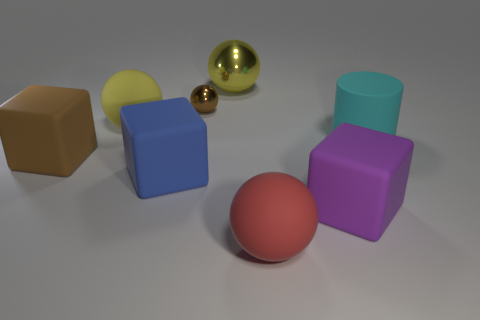Subtract all large brown blocks. How many blocks are left? 2 Add 1 red matte objects. How many objects exist? 9 Subtract all yellow balls. How many balls are left? 2 Subtract 1 cylinders. How many cylinders are left? 0 Subtract all cubes. How many objects are left? 5 Subtract all cyan cubes. Subtract all red spheres. How many cubes are left? 3 Add 3 tiny shiny balls. How many tiny shiny balls exist? 4 Subtract 0 green spheres. How many objects are left? 8 Subtract all cyan blocks. How many green spheres are left? 0 Subtract all green shiny cylinders. Subtract all cylinders. How many objects are left? 7 